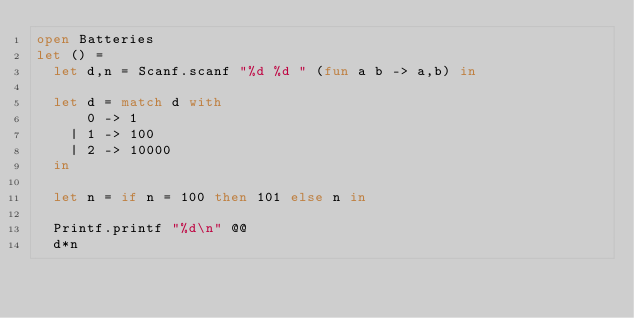<code> <loc_0><loc_0><loc_500><loc_500><_OCaml_>open Batteries
let () =
  let d,n = Scanf.scanf "%d %d " (fun a b -> a,b) in

  let d = match d with
      0 -> 1
    | 1 -> 100
    | 2 -> 10000
  in

  let n = if n = 100 then 101 else n in

  Printf.printf "%d\n" @@
  d*n
</code> 